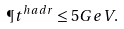Convert formula to latex. <formula><loc_0><loc_0><loc_500><loc_500>\P t ^ { h a d r } \leq 5 G e V .</formula> 